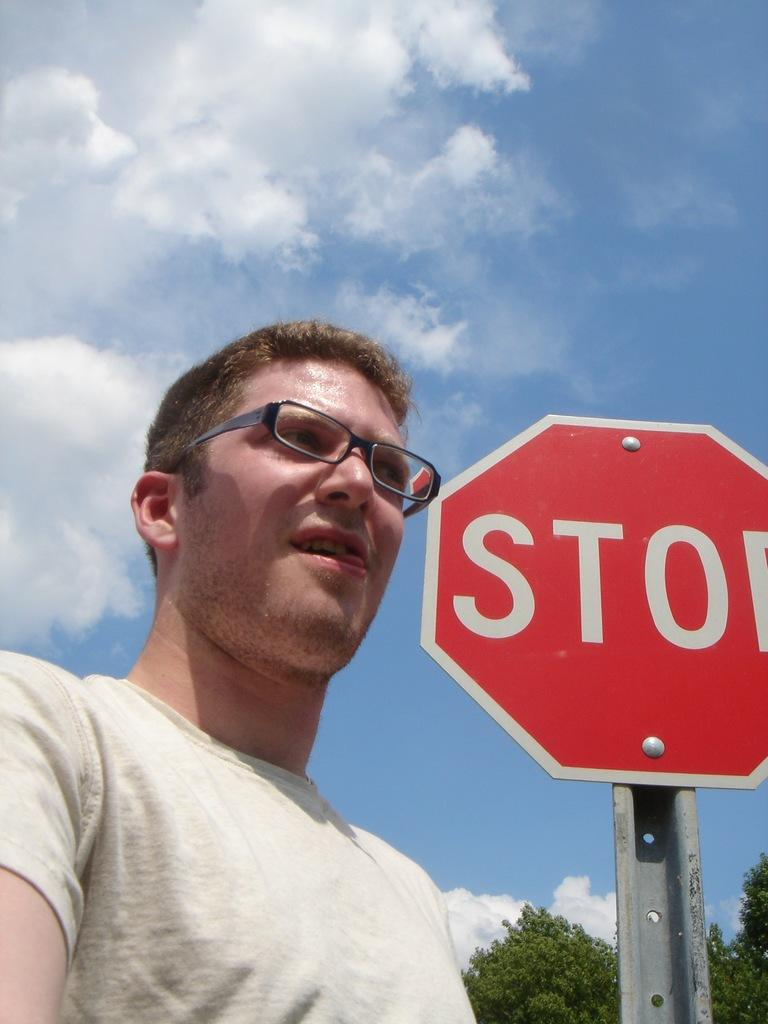<image>
Share a concise interpretation of the image provided. a man in glasses and red hair in front of a Stop sign 